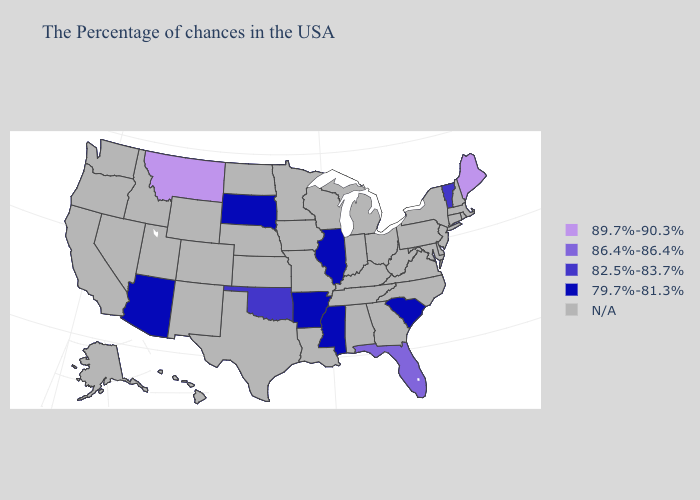What is the value of Nevada?
Be succinct. N/A. Does the first symbol in the legend represent the smallest category?
Write a very short answer. No. What is the lowest value in the Northeast?
Concise answer only. 82.5%-83.7%. What is the lowest value in the USA?
Quick response, please. 79.7%-81.3%. Name the states that have a value in the range 86.4%-86.4%?
Give a very brief answer. Florida. Is the legend a continuous bar?
Quick response, please. No. Which states have the highest value in the USA?
Give a very brief answer. Maine, Montana. Does the first symbol in the legend represent the smallest category?
Concise answer only. No. Does Montana have the lowest value in the West?
Write a very short answer. No. Which states have the lowest value in the USA?
Concise answer only. South Carolina, Illinois, Mississippi, Arkansas, South Dakota, Arizona. What is the lowest value in states that border Louisiana?
Be succinct. 79.7%-81.3%. Does Maine have the lowest value in the USA?
Concise answer only. No. 